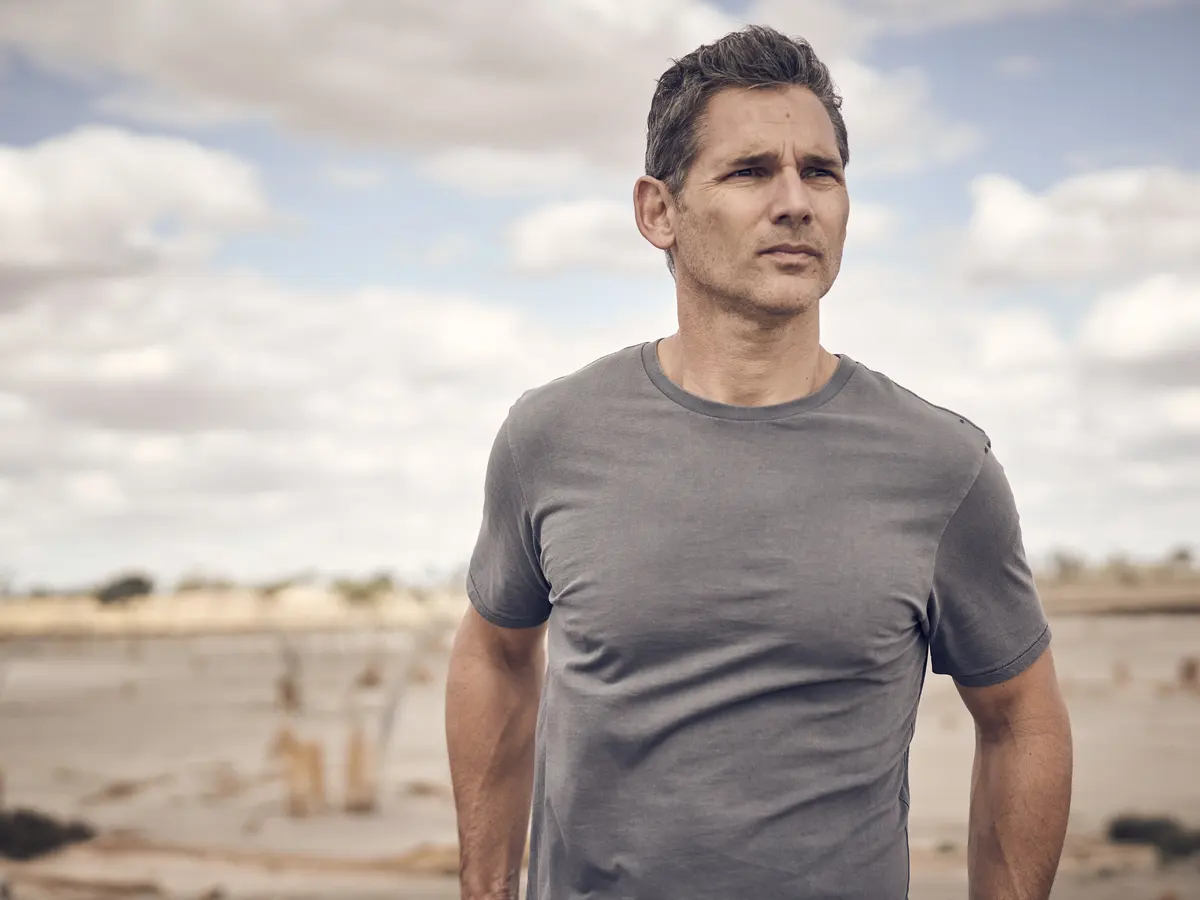If this scene were part of a movie, what genre would it likely belong to and why? If this scene were part of a movie, it would likely belong to the drama or romance genre. The man's contemplative stance amidst a serene yet somber beach setting hints at emotional depth and introspection, qualities commonly explored in dramatic or romantic narratives. The overcast sky and solitary environment further support themes of personal struggle, growth, or the complexities of relationships. 